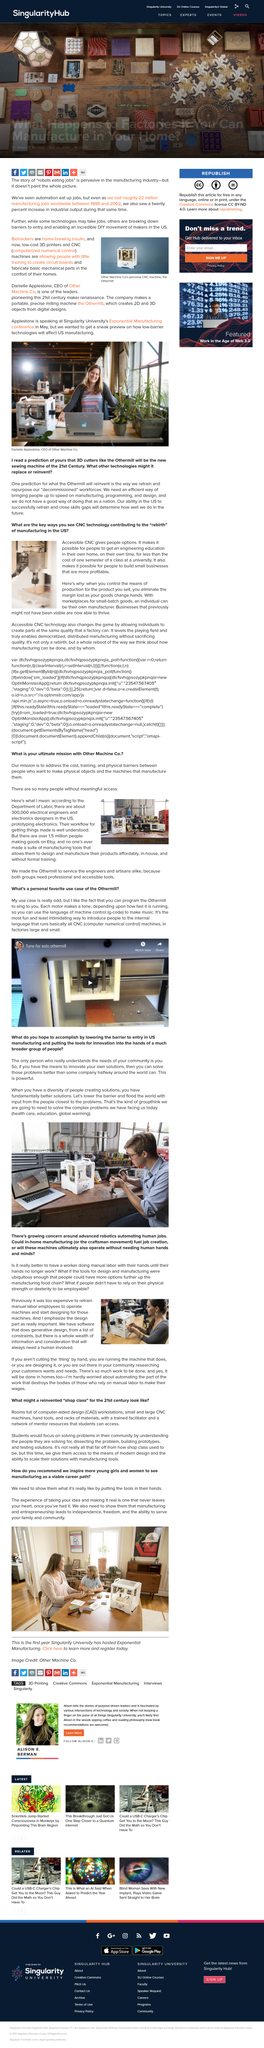Give some essential details in this illustration. There is a growing concern that the advancement of robotics technology is leading to the automation of human jobs. According to Etsy, over 1.5 million individuals are currently making goods on the platform. Accessible CNC education can provide people with valuable knowledge about engineering at a fraction of the cost of a semester of classes at a university. Today, we face complex and pressing issues such as healthcare, education, and global warming that require innovative solutions. At Other Machine Co., our ultimate mission is to eliminate the financial, educational, and physical obstacles that prevent individuals from creating physical objects using advanced manufacturing machines. 